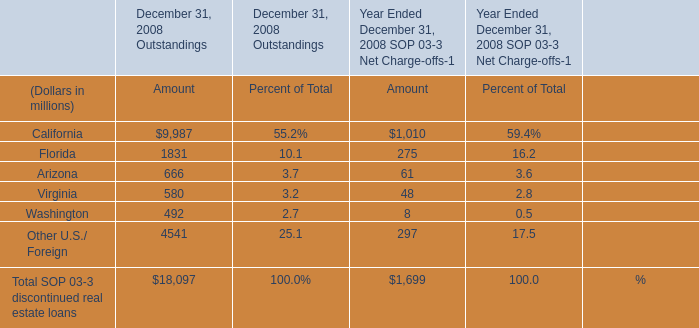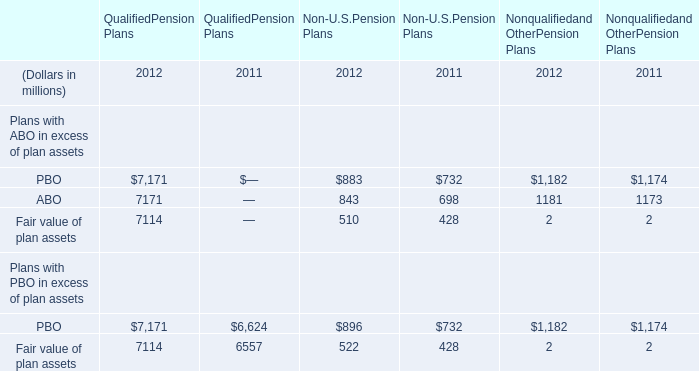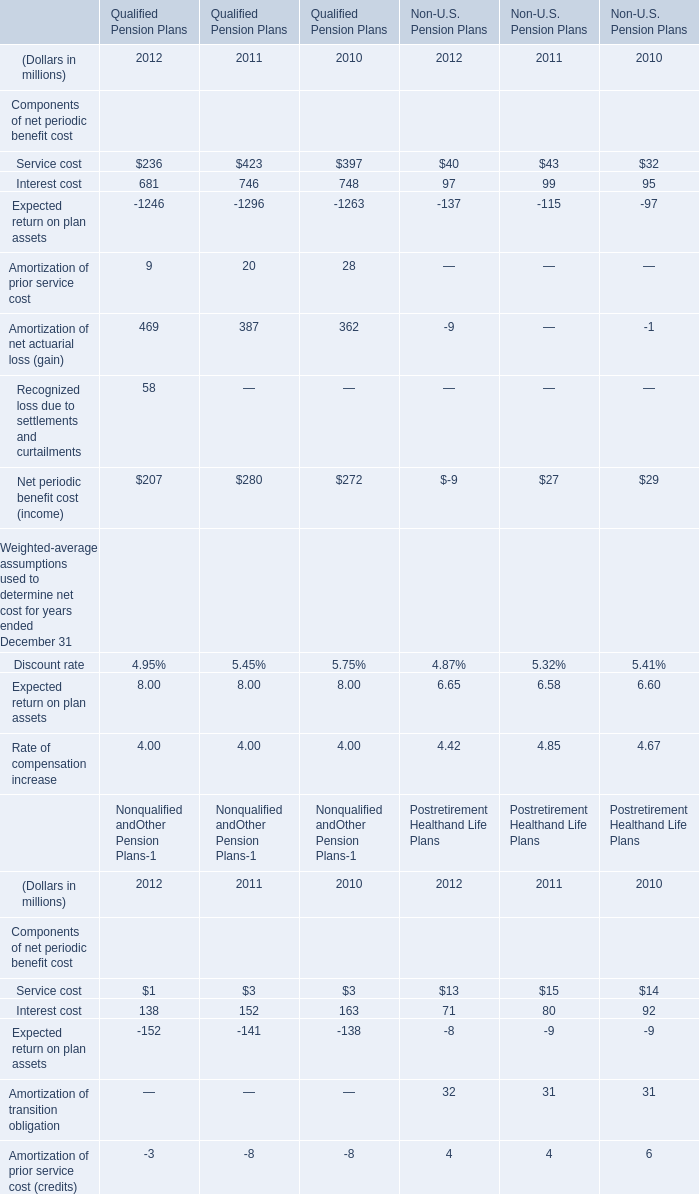What's the total amount of the Service cost for Qualified Pension Plans in the years where Interest cost is greater than 700? (in million) 
Computations: (423 + 397)
Answer: 820.0. 